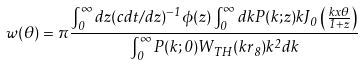Convert formula to latex. <formula><loc_0><loc_0><loc_500><loc_500>w ( \theta ) = \pi \frac { \int _ { 0 } ^ { \infty } d z ( c d t / d z ) ^ { - 1 } \phi ( z ) \int _ { 0 } ^ { \infty } d k P ( k ; z ) k J _ { 0 } \left ( \frac { k x \theta } { 1 + z } \right ) } { \int _ { 0 } ^ { \infty } P ( k ; 0 ) W _ { T H } ( k r _ { 8 } ) k ^ { 2 } d k }</formula> 